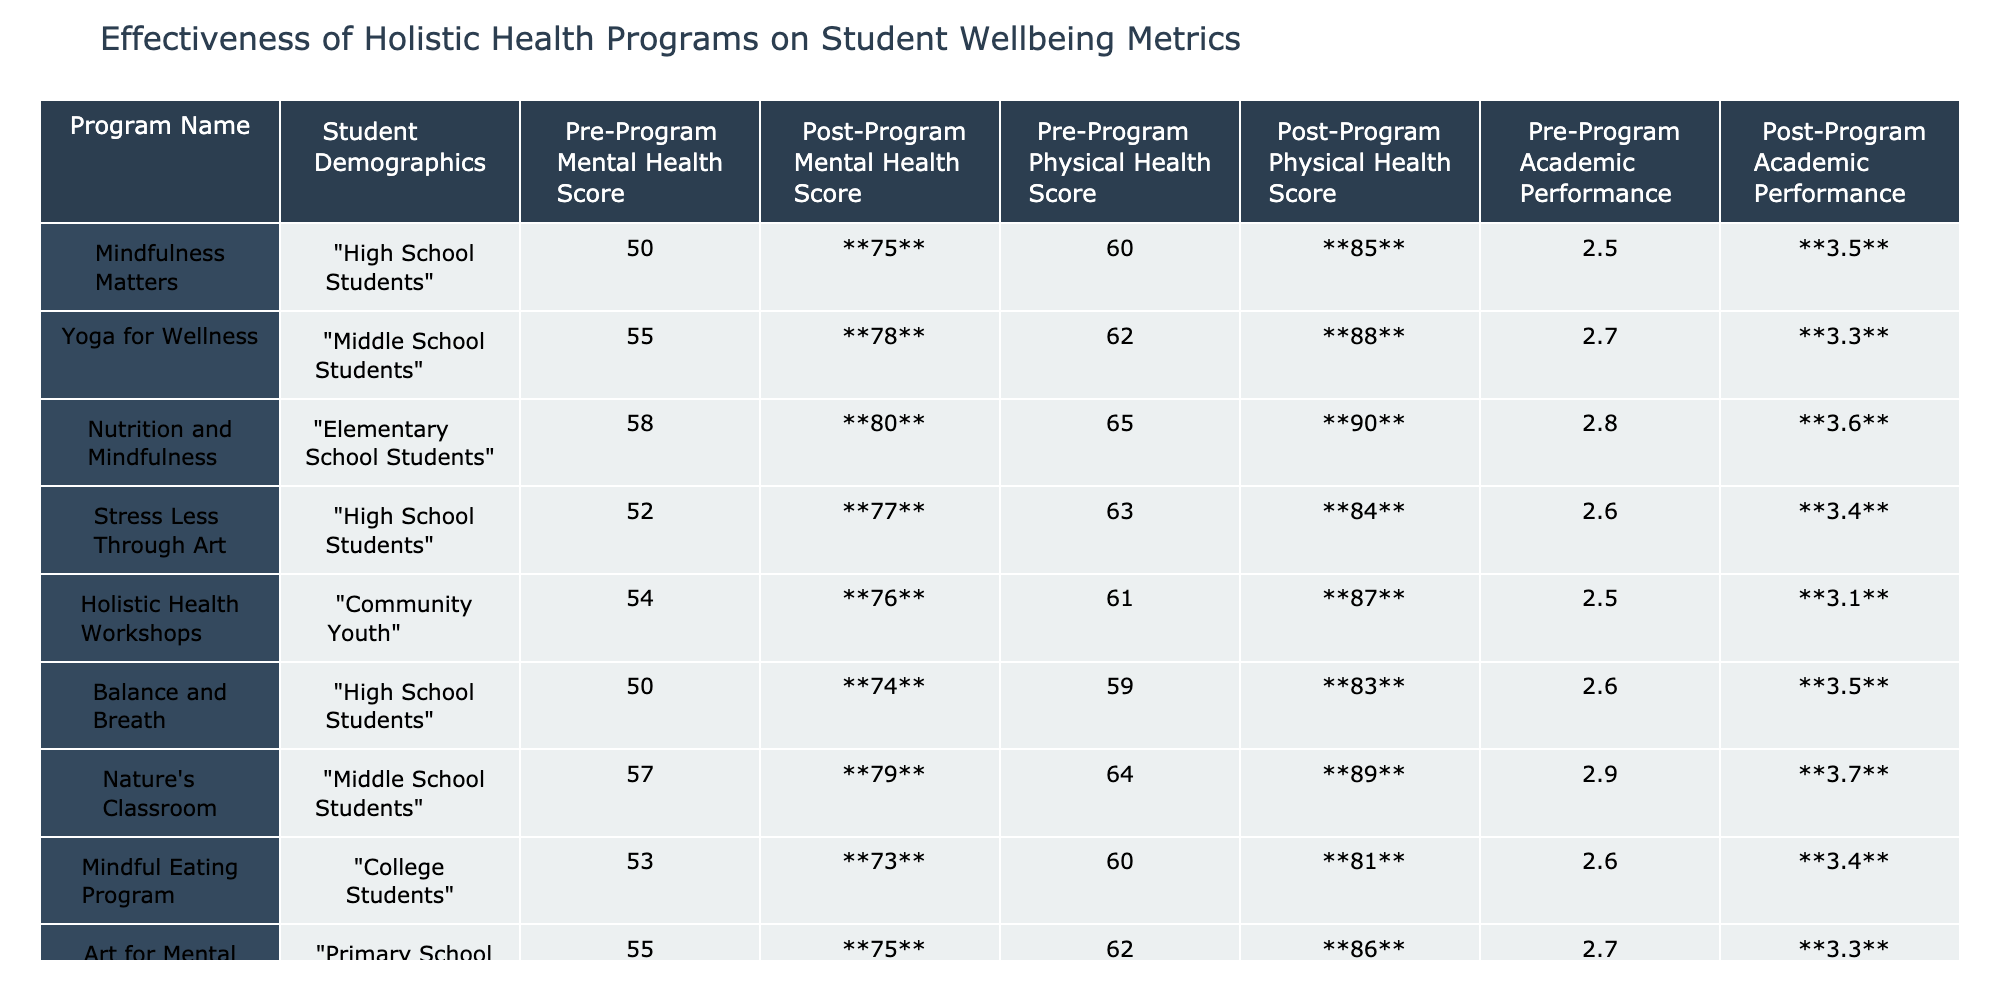What is the highest Post-Program Mental Health Score? The highest Post-Program Mental Health Score in the table is from the "Nutrition and Mindfulness" program, with a score of **80**.
Answer: 80 What is the average Pre-Program Academic Performance for the programs listed? The Pre-Program Academic Performances are 2.5, 2.7, 2.8, 2.6, 2.5, 2.6, 2.9, 2.6, and 2.7. Summing these gives 2.5 + 2.7 + 2.8 + 2.6 + 2.5 + 2.6 + 2.9 + 2.6 + 2.7 = 23.3. Dividing by 9 gives an average of approximately 2.59.
Answer: 2.59 Did "Stress Less Through Art" show improvement in Physical Health Score? The Pre-Program Physical Health Score for "Stress Less Through Art" was 63, and it improved to **84** post-program, indicating improvement.
Answer: Yes Which program had the most significant increase in Mental Health Score? To find this, we calculate the differences: "Mindfulness Matters" (75-50=25), "Yoga for Wellness" (78-55=23), "Nutrition and Mindfulness" (80-58=22), "Stress Less Through Art" (77-52=25), "Holistic Health Workshops" (76-54=22), "Balance and Breath" (74-50=24), "Nature's Classroom" (79-57=22), "Mindful Eating Program" (73-53=20), "Art for Mental Health" (75-55=20). The highest increase is **25**, seen in "Mindfulness Matters" and "Stress Less Through Art".
Answer: Mindfulness Matters and Stress Less Through Art What was the Post-Program Physical Health Score of the "Nature's Classroom" program? The Post-Program Physical Health Score for the "Nature's Classroom" is **79**.
Answer: 79 Which program had the lowest Pre-Program Mental Health Score? The lowest Pre-Program Mental Health Score is from the "Balance and Breath" program, with a score of 50.
Answer: 50 How much improvement in Academic Performance did "Nutrition and Mindfulness" achieve? The Academic Performance went from 2.8 to **3.6**, which is an improvement of 3.6 - 2.8 = 0.8.
Answer: 0.8 Is the Post-Program Academic Performance for "Yoga for Wellness" higher than that of "Holistic Health Workshops"? "Yoga for Wellness" has a Post-Program Academic Performance of **3.3**, while "Holistic Health Workshops" has **3.1**, so yes, it is higher.
Answer: Yes What is the total increase in Mental Health Scores across all programs? The increases for each program are: 25, 23, 22, 25, 22, 24, 22, 20, 20. Summing these gives 25 + 23 + 22 + 25 + 22 + 24 + 22 + 20 + 20 = 193.
Answer: 193 Which demographic had the highest Post-Program Physical Health Score and what was it? The "Nutrition and Mindfulness" program for Elementary School Students had the highest Post-Program Physical Health Score of **90**.
Answer: 90 